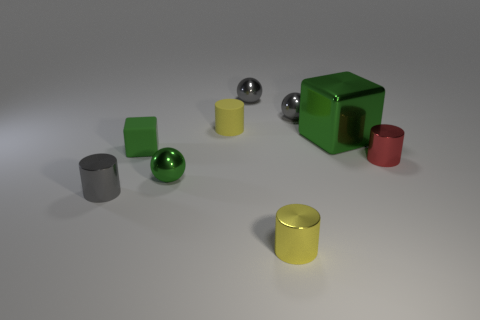Are any tiny green metallic cylinders visible?
Make the answer very short. No. Is there a small object that is on the left side of the yellow cylinder that is behind the matte object that is in front of the yellow rubber cylinder?
Offer a terse response. Yes. What number of large things are balls or cylinders?
Keep it short and to the point. 0. What color is the matte block that is the same size as the yellow matte object?
Offer a terse response. Green. How many small yellow things are on the left side of the yellow metallic thing?
Your response must be concise. 1. Is there a large cube that has the same material as the red thing?
Provide a succinct answer. Yes. What is the shape of the large shiny thing that is the same color as the tiny rubber cube?
Provide a succinct answer. Cube. There is a rubber object that is behind the tiny green block; what is its color?
Your answer should be compact. Yellow. Are there an equal number of small yellow matte cylinders in front of the metallic cube and red metallic objects that are in front of the red object?
Give a very brief answer. Yes. The tiny yellow cylinder in front of the block that is to the left of the large thing is made of what material?
Your response must be concise. Metal. 